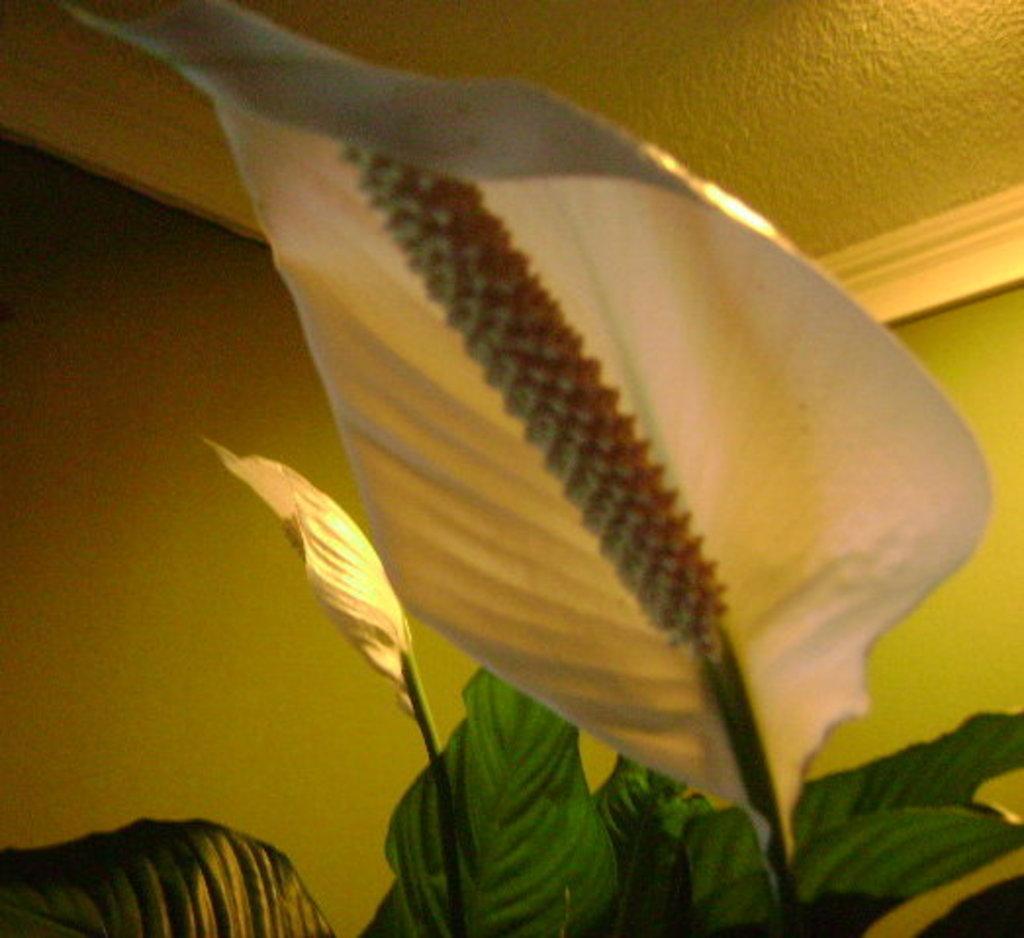Can you describe this image briefly? In this image in the middle there is a leaf. At the bottom there is a plant. leaves. In the background there is a wall, roof and light. 